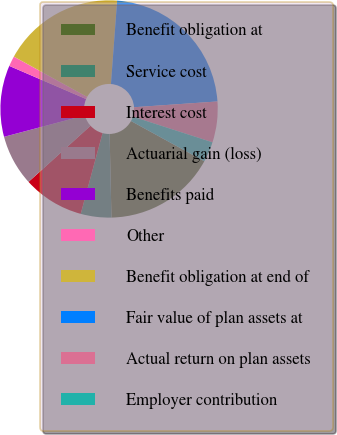<chart> <loc_0><loc_0><loc_500><loc_500><pie_chart><fcel>Benefit obligation at<fcel>Service cost<fcel>Interest cost<fcel>Actuarial gain (loss)<fcel>Benefits paid<fcel>Other<fcel>Benefit obligation at end of<fcel>Fair value of plan assets at<fcel>Actual return on plan assets<fcel>Employer contribution<nl><fcel>16.66%<fcel>4.55%<fcel>9.09%<fcel>7.58%<fcel>10.61%<fcel>1.52%<fcel>18.18%<fcel>22.72%<fcel>6.06%<fcel>3.03%<nl></chart> 